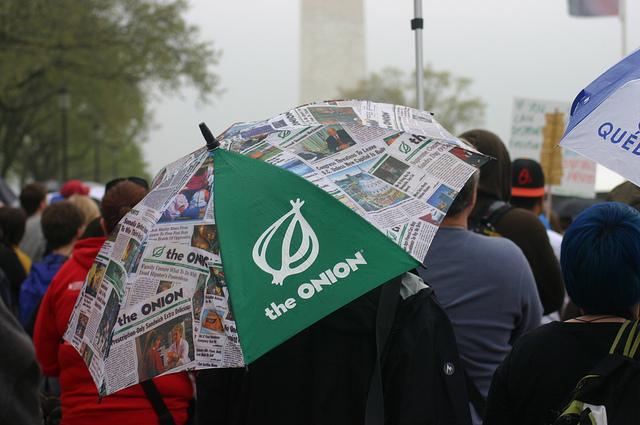What kind of business is The Onion?
Give a very brief answer. Newspaper. Is there a person with a backpack in the scene?
Short answer required. Yes. What does the umbrella say?
Write a very short answer. The onion. Is there any vegetation?
Write a very short answer. Yes. 